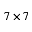<formula> <loc_0><loc_0><loc_500><loc_500>7 \times 7</formula> 